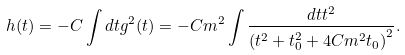Convert formula to latex. <formula><loc_0><loc_0><loc_500><loc_500>h ( t ) = - C \int d t g ^ { 2 } ( t ) = - C m ^ { 2 } \int \frac { d t t ^ { 2 } } { \left ( t ^ { 2 } + t _ { 0 } ^ { 2 } + 4 C m ^ { 2 } t _ { 0 } \right ) ^ { 2 } } .</formula> 